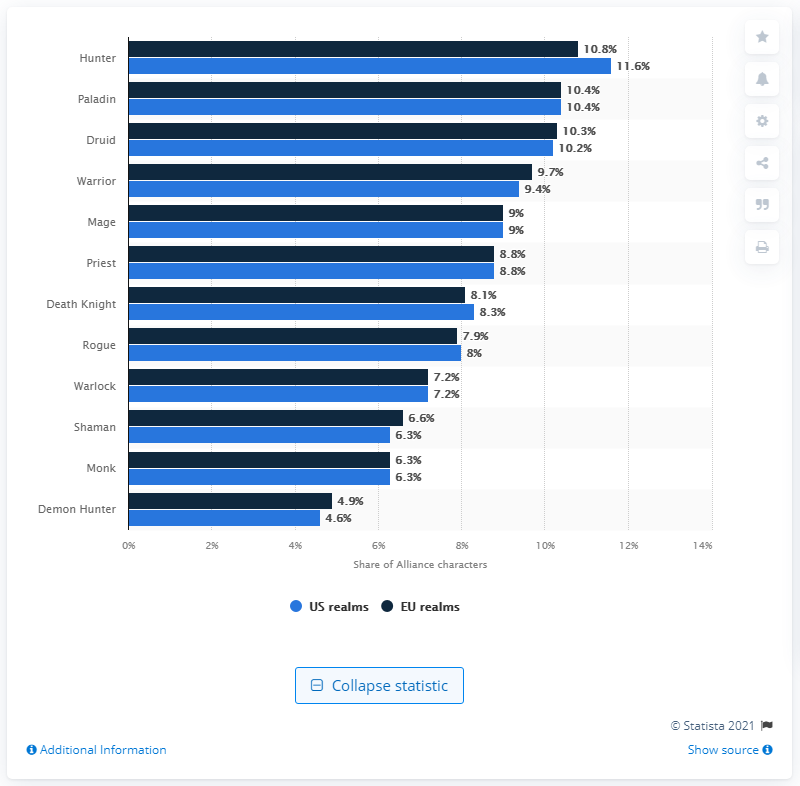Give some essential details in this illustration. The percentage of highest characters in the US realm is significantly higher than the minimum characters in the EU realm, at 6.7 times higher. Hunter, the character, has the highest percentage in US realms over the years. 